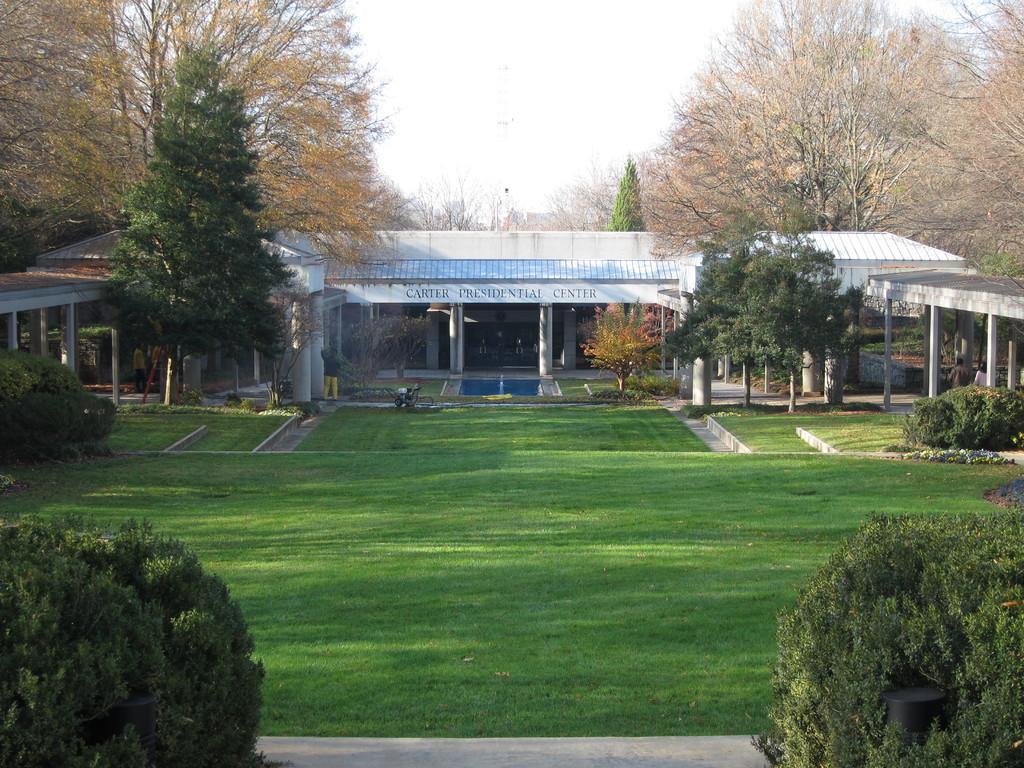In one or two sentences, can you explain what this image depicts? In the image we can see shed construction and there is a poster and text on it. Here we can see the grass, plants, trees and the sky. 